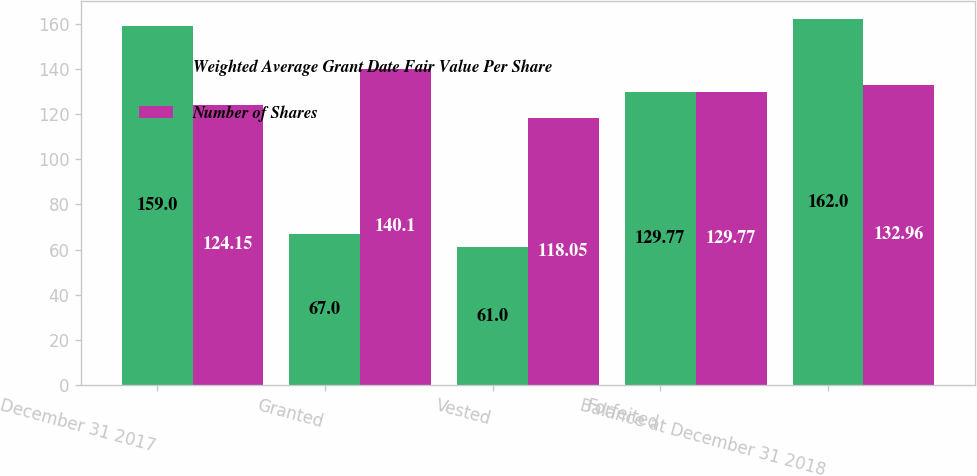Convert chart. <chart><loc_0><loc_0><loc_500><loc_500><stacked_bar_chart><ecel><fcel>December 31 2017<fcel>Granted<fcel>Vested<fcel>Forfeited<fcel>Balance at December 31 2018<nl><fcel>Weighted Average Grant Date Fair Value Per Share<fcel>159<fcel>67<fcel>61<fcel>129.77<fcel>162<nl><fcel>Number of Shares<fcel>124.15<fcel>140.1<fcel>118.05<fcel>129.77<fcel>132.96<nl></chart> 